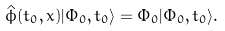<formula> <loc_0><loc_0><loc_500><loc_500>\hat { \phi } ( t _ { 0 } , { x } ) | \Phi _ { 0 } , t _ { 0 } \rangle = \Phi _ { 0 } | \Phi _ { 0 } , t _ { 0 } \rangle .</formula> 